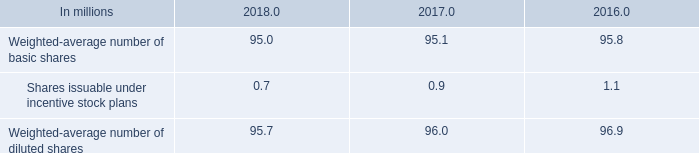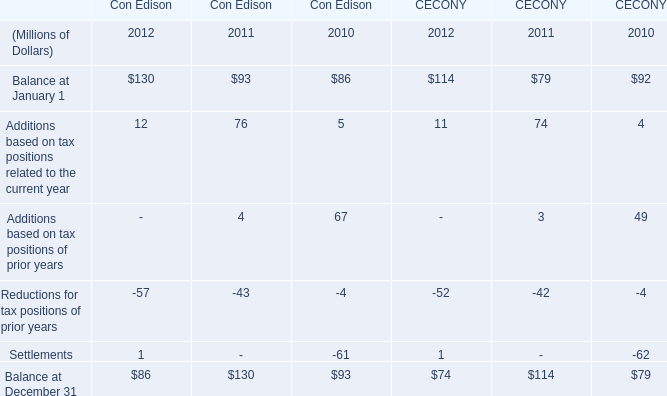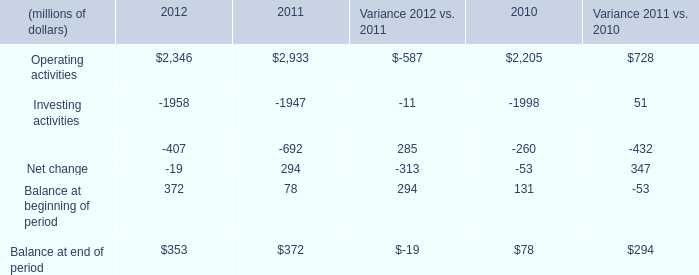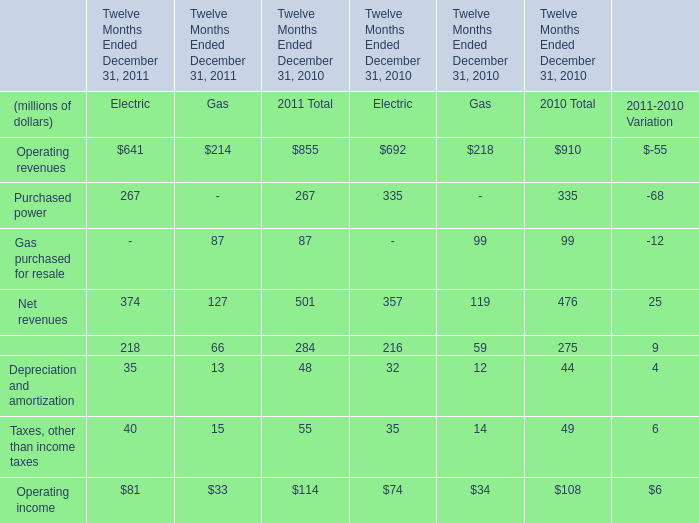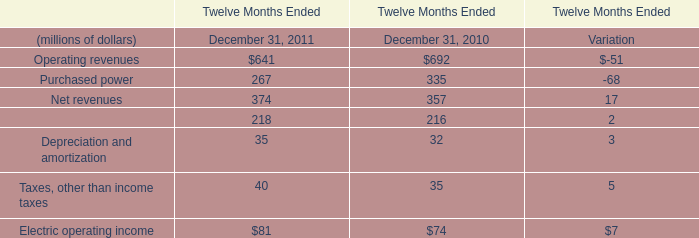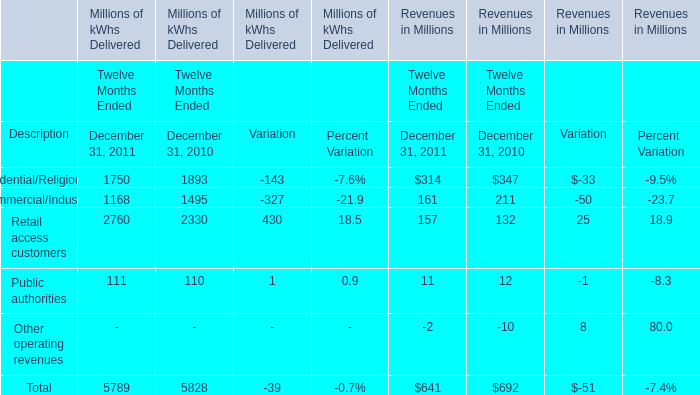What was the average value of Residential/Religious(a), Commercial/Industrial, Retail access customers in Revenues in Millions for Twelve Months Ended in 2011? (in million) 
Computations: (((314 + 161) + 157) / 3)
Answer: 210.66667. 